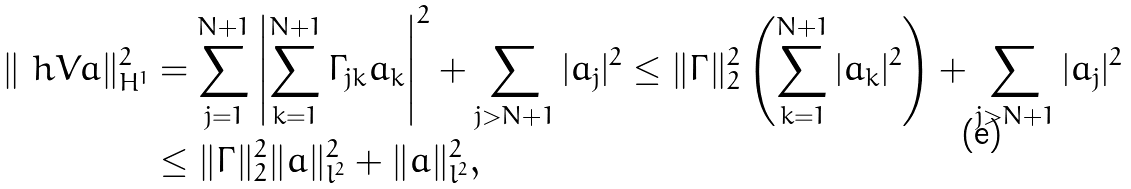<formula> <loc_0><loc_0><loc_500><loc_500>\| \ h V a \| _ { H ^ { 1 } } ^ { 2 } & = \sum _ { j = 1 } ^ { N + 1 } \left | \sum _ { k = 1 } ^ { N + 1 } \Gamma _ { j k } a _ { k } \right | ^ { 2 } + \sum _ { j > N + 1 } | a _ { j } | ^ { 2 } \leq \| \Gamma \| _ { 2 } ^ { 2 } \left ( \sum _ { k = 1 } ^ { N + 1 } | a _ { k } | ^ { 2 } \right ) + \sum _ { j > N + 1 } | a _ { j } | ^ { 2 } \\ & \leq \| \Gamma \| _ { 2 } ^ { 2 } \| a \| _ { l ^ { 2 } } ^ { 2 } + \| a \| _ { l ^ { 2 } } ^ { 2 } ,</formula> 